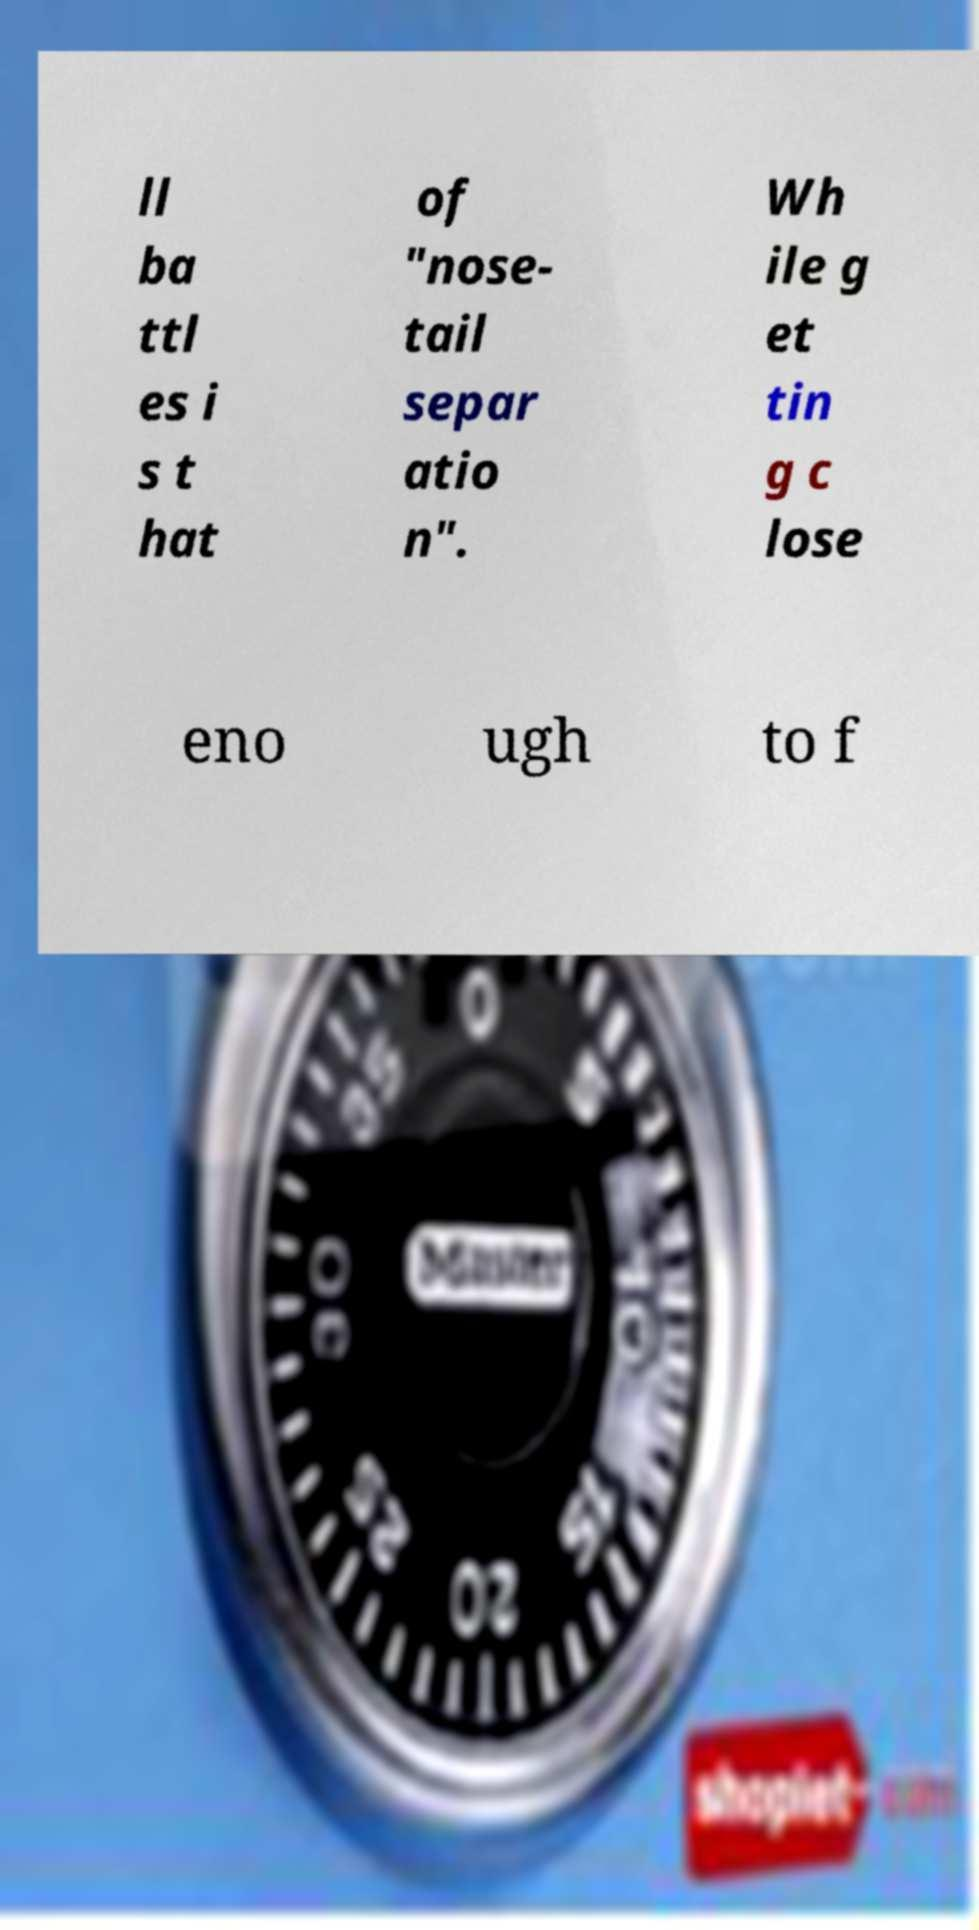What messages or text are displayed in this image? I need them in a readable, typed format. ll ba ttl es i s t hat of "nose- tail separ atio n". Wh ile g et tin g c lose eno ugh to f 